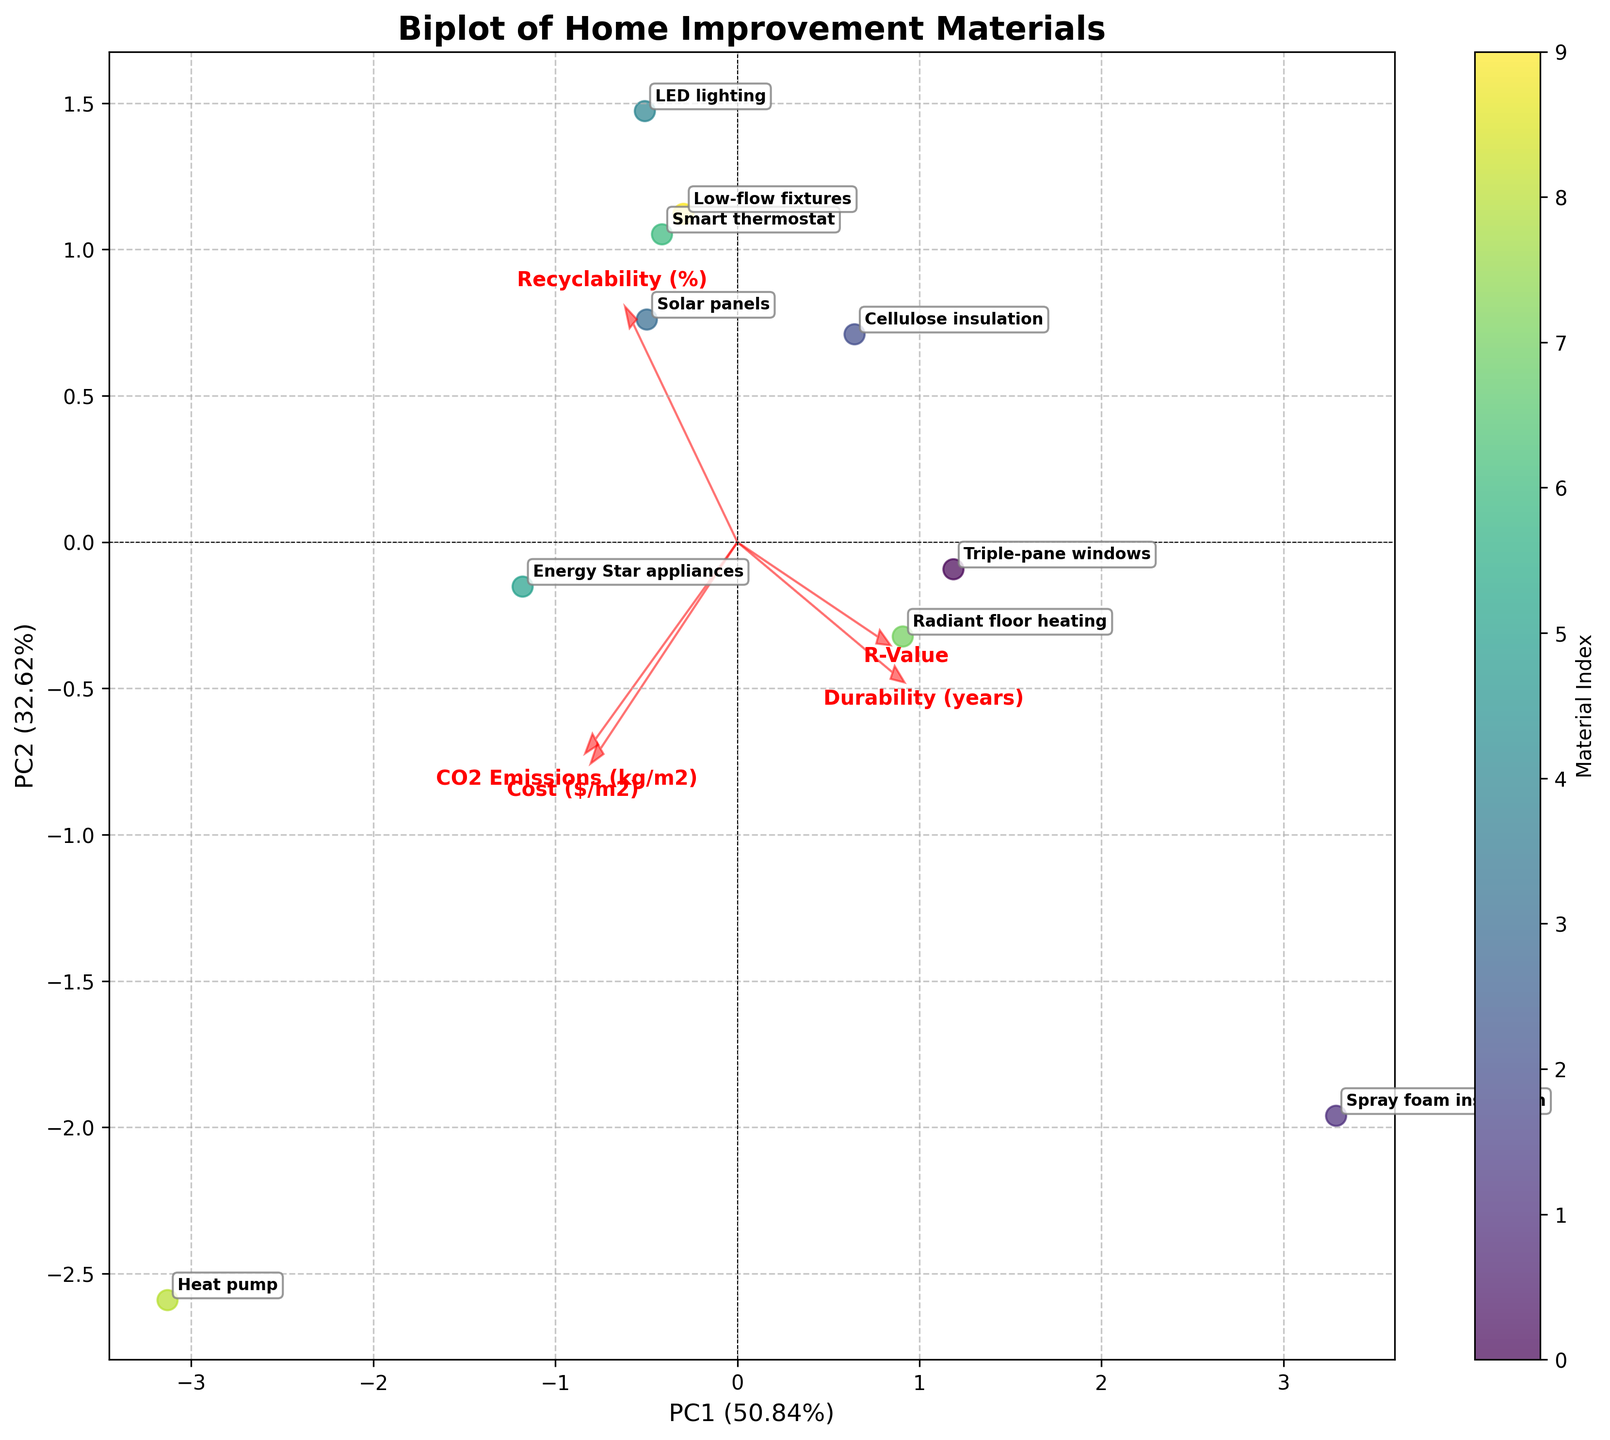How many different materials are represented in the biplot? Count the number of labeled points shown on the biplot.
Answer: 10 What do the arrows represent in the biplot? The arrows represent the loading vectors of the original features, showing their contribution to the Principal Components.
Answer: Loadings of features Which material has the highest recyclability? Identify and locate the material label closest to the arrow indicating high recyclability.
Answer: Solar panels Which material shows the highest durability and is farthest to the right along PC1? Locate the point farthest to the right along the PC1 axis and check the associated material label.
Answer: Radiant floor heating What are the labels on the x and y axes of the biplot? Look at the axis labels displayed on the plot.
Answer: PC1 and PC2 Which material is most strongly associated with high CO2 emissions? Find the point that is placed near the arrow indicating high CO2 emissions.
Answer: Heat pump How do the costs of Energy Star appliances compare to those of LED lighting? Check the positioning of Energy Star appliances and LED lighting relative to the cost arrow. Energy Star appliances are positioned farther in the direction of higher cost compared to LED lighting.
Answer: Greater Are there any materials that have a similar position in the biplot and thus might have similar properties? Look for clusters or points that are close to each other in the biplot.
Answer: Triple-pane windows and Spray foam insulation 